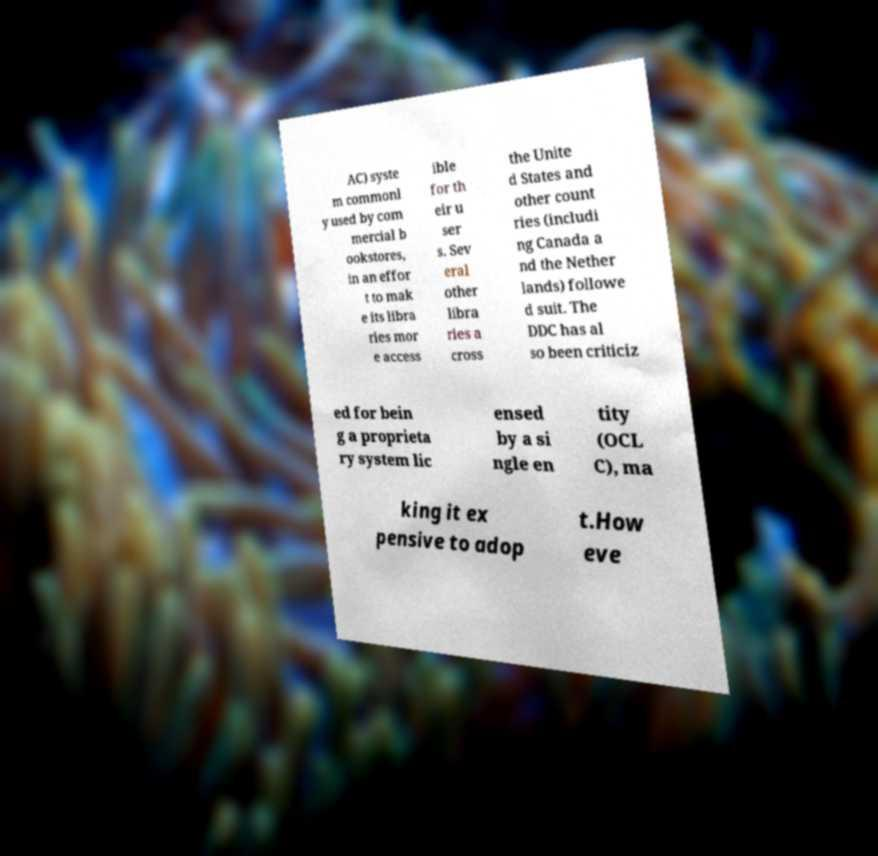I need the written content from this picture converted into text. Can you do that? AC) syste m commonl y used by com mercial b ookstores, in an effor t to mak e its libra ries mor e access ible for th eir u ser s. Sev eral other libra ries a cross the Unite d States and other count ries (includi ng Canada a nd the Nether lands) followe d suit. The DDC has al so been criticiz ed for bein g a proprieta ry system lic ensed by a si ngle en tity (OCL C), ma king it ex pensive to adop t.How eve 